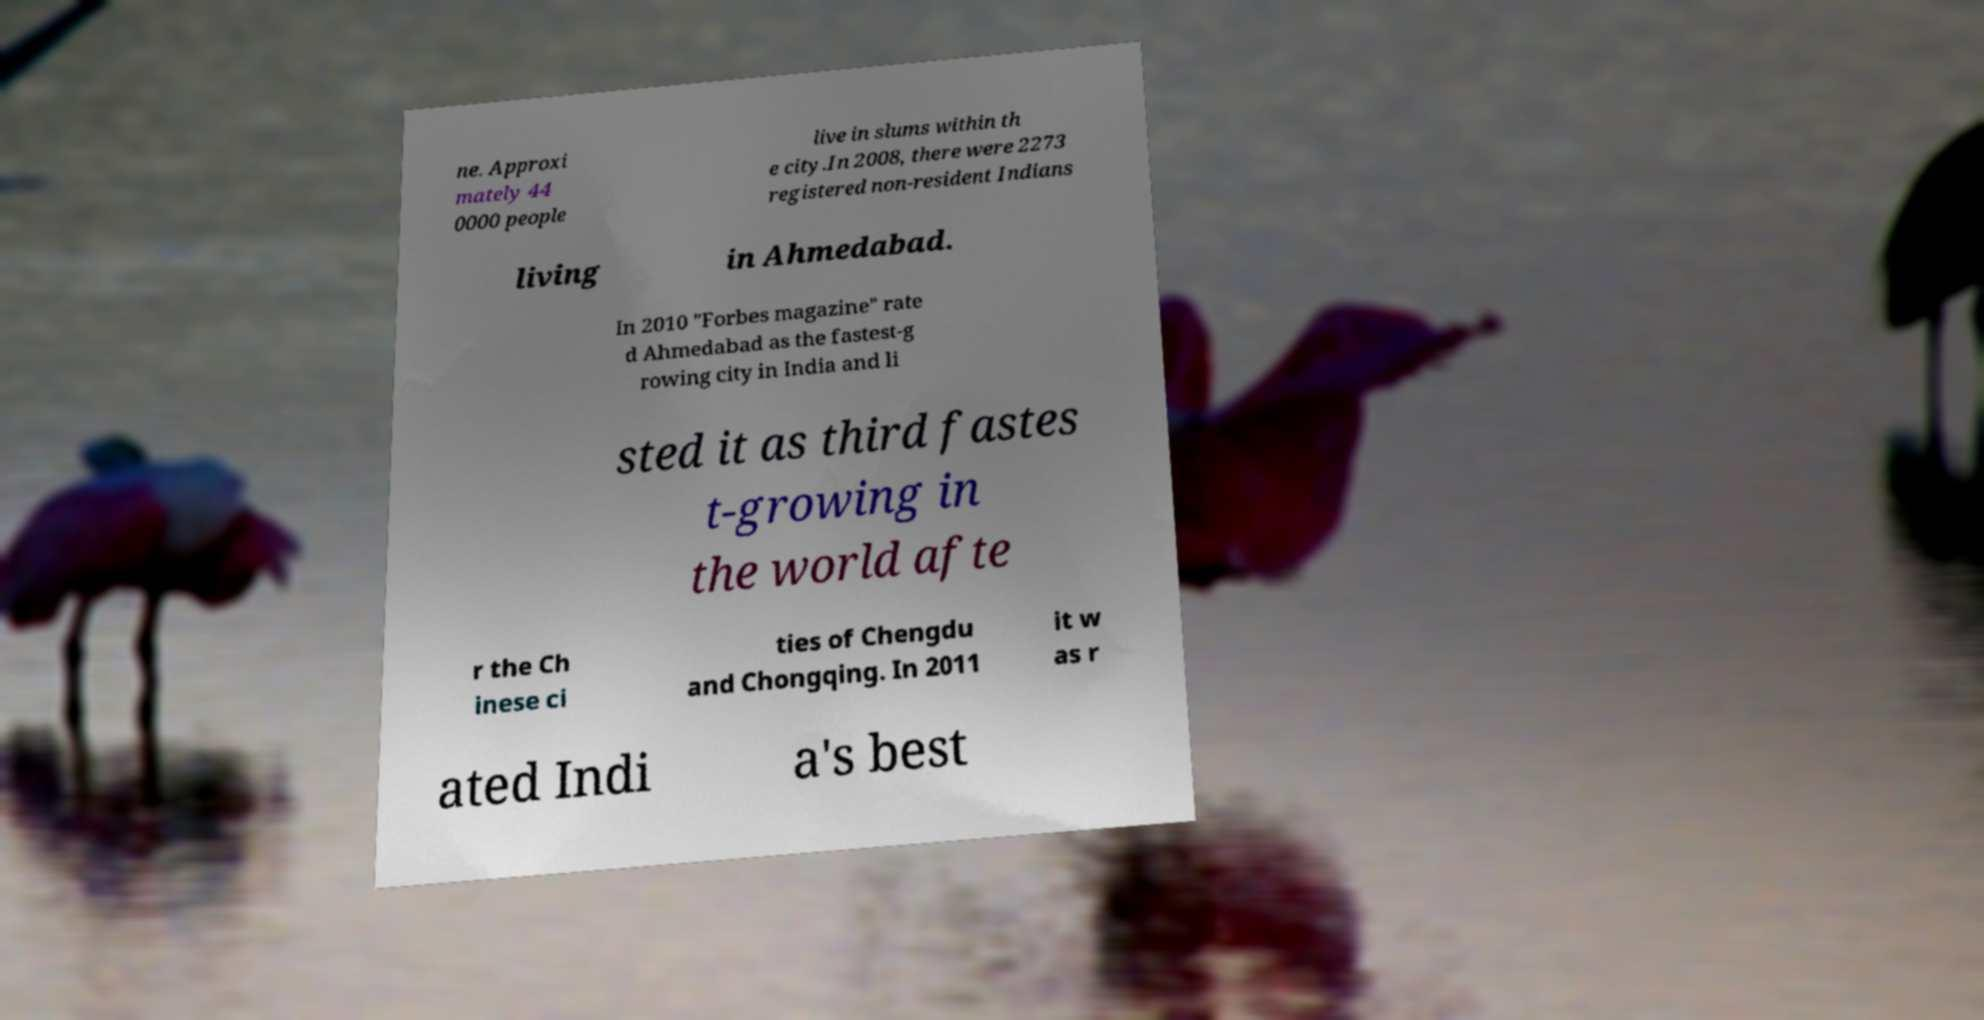Can you accurately transcribe the text from the provided image for me? ne. Approxi mately 44 0000 people live in slums within th e city.In 2008, there were 2273 registered non-resident Indians living in Ahmedabad. In 2010 "Forbes magazine" rate d Ahmedabad as the fastest-g rowing city in India and li sted it as third fastes t-growing in the world afte r the Ch inese ci ties of Chengdu and Chongqing. In 2011 it w as r ated Indi a's best 